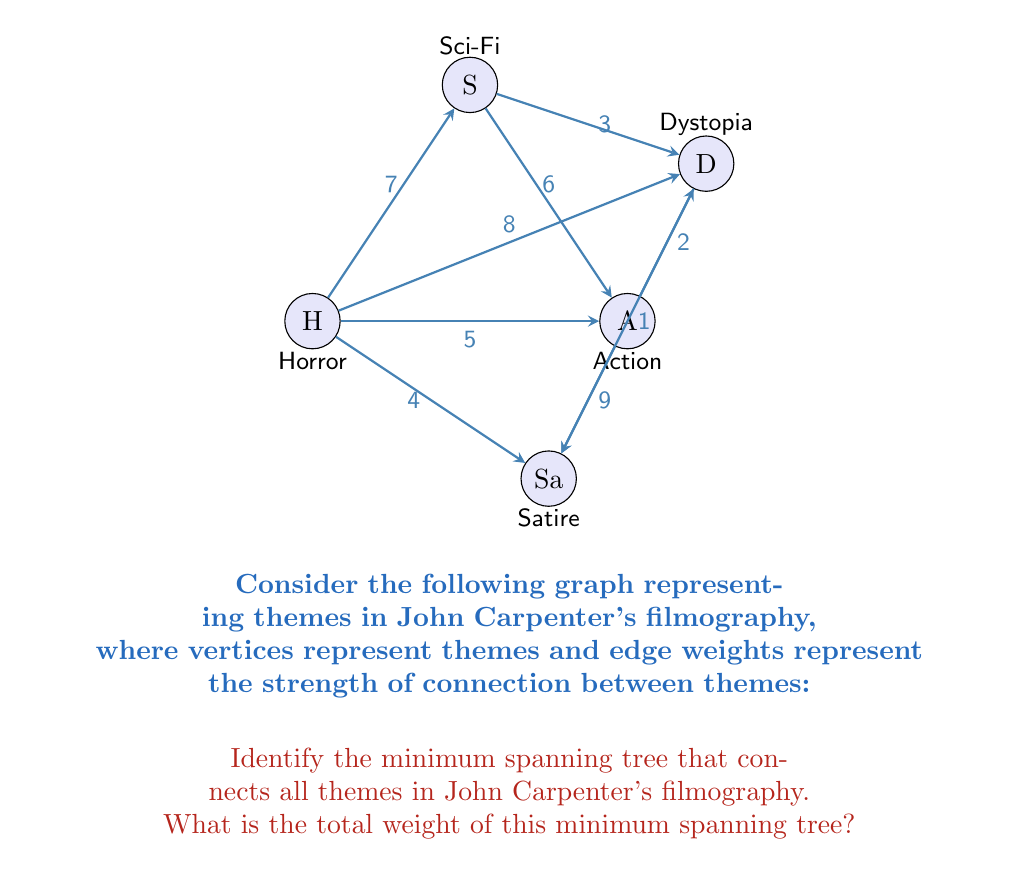Can you answer this question? To find the minimum spanning tree (MST) of this graph, we can use Kruskal's algorithm:

1) Sort all edges by weight in ascending order:
   (Dystopia, Satire): 1
   (Action, Dystopia): 2
   (Sci-Fi, Dystopia): 3
   (Horror, Satire): 4
   (Horror, Action): 5
   (Sci-Fi, Action): 6
   (Horror, Sci-Fi): 7
   (Horror, Dystopia): 8
   (Action, Satire): 9

2) Start with an empty MST and add edges in this order, skipping any that would create a cycle:

   - Add (Dystopia, Satire): 1
   - Add (Action, Dystopia): 2
   - Add (Sci-Fi, Dystopia): 3
   - Add (Horror, Satire): 4

3) At this point, all vertices are connected, and we have our MST.

4) The total weight of the MST is the sum of the weights of these edges:
   $$1 + 2 + 3 + 4 = 10$$

Therefore, the minimum spanning tree has a total weight of 10.

This MST represents the most efficient way to connect all the major themes in John Carpenter's filmography, highlighting the interconnectedness of his work across genres.
Answer: 10 